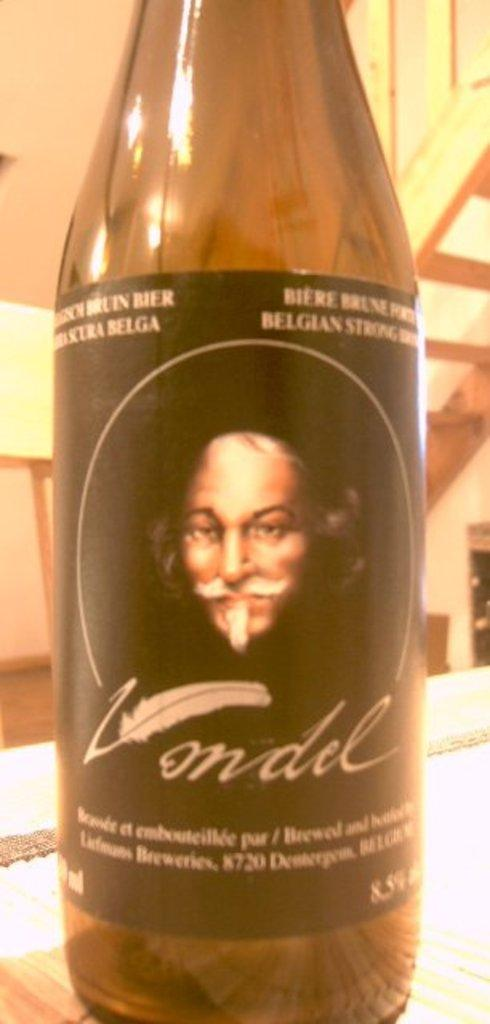What object is present in the image? There is a bottle in the image. What is on the bottle? The bottle has a sticker on it. What is depicted on the sticker? The sticker features a feather and a man. Where is the bottle located? The bottle is placed on a table. What can be seen in the background of the image? There is a wall and wooden steps in the background of the image. What type of rhythm can be heard coming from the bottle in the image? There is no sound or rhythm associated with the bottle in the image. What advice is given on the sticker on the bottle? The sticker on the bottle features a feather and a man, but it does not provide any advice. 